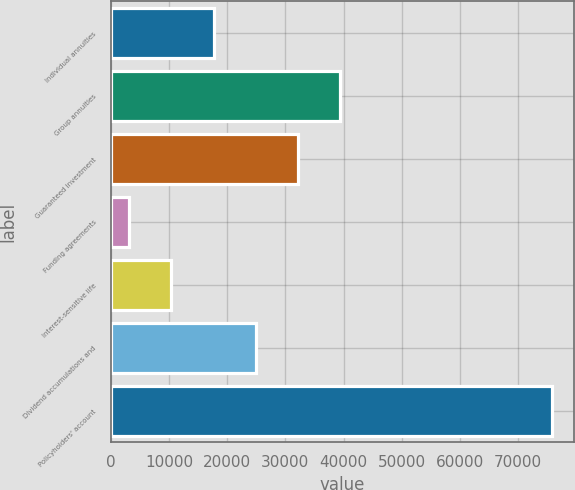<chart> <loc_0><loc_0><loc_500><loc_500><bar_chart><fcel>Individual annuities<fcel>Group annuities<fcel>Guaranteed investment<fcel>Funding agreements<fcel>Interest-sensitive life<fcel>Dividend accumulations and<fcel>Policyholders' account<nl><fcel>17674.2<fcel>39465<fcel>32201.4<fcel>3147<fcel>10410.6<fcel>24937.8<fcel>75783<nl></chart> 